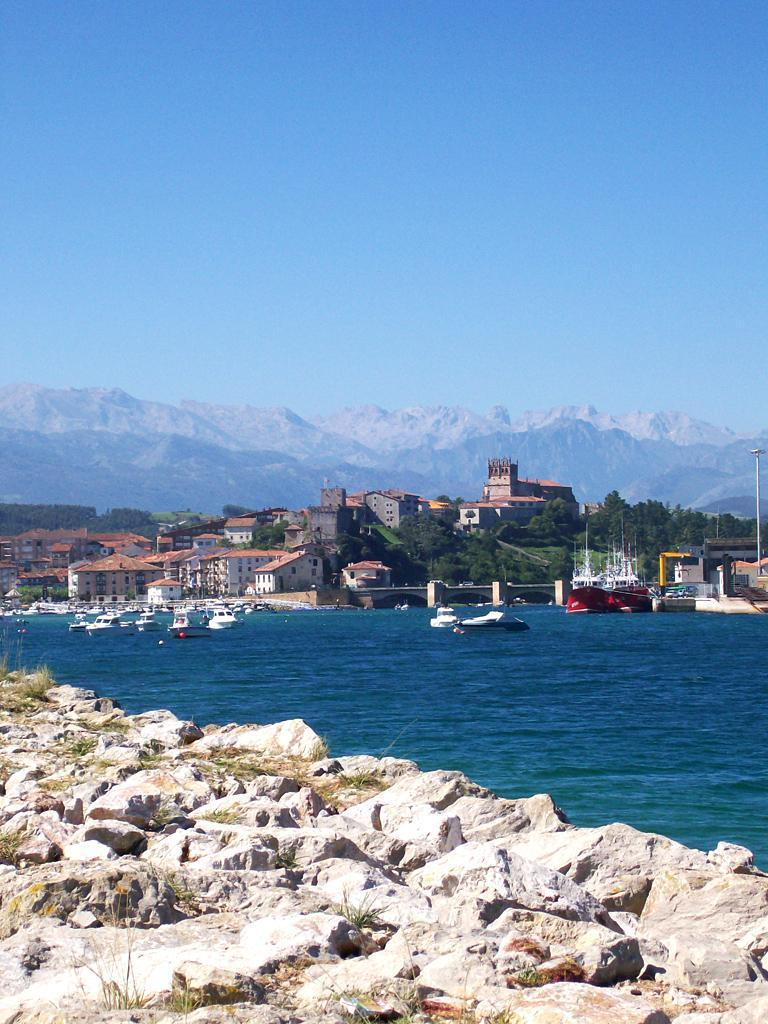What is present in large numbers in the water in the image? There are many boats in the water in the image. What is the primary element visible in the image? Water is visible in the image. What type of terrain can be seen in the image in the image? There are stones, grass, and trees in the image. What type of structure is present in the image? There is a building in the image. What type of man-made object is present in the image? There is a light pole in the image. What type of natural landform is present in the image? There is a mountain in the image. What is the color of the sky in the image? The sky is pale blue in color. What language is the bear speaking in the image? There is no bear present in the image, and therefore no language being spoken. How many nails are visible in the image? There are no nails visible in the image. 